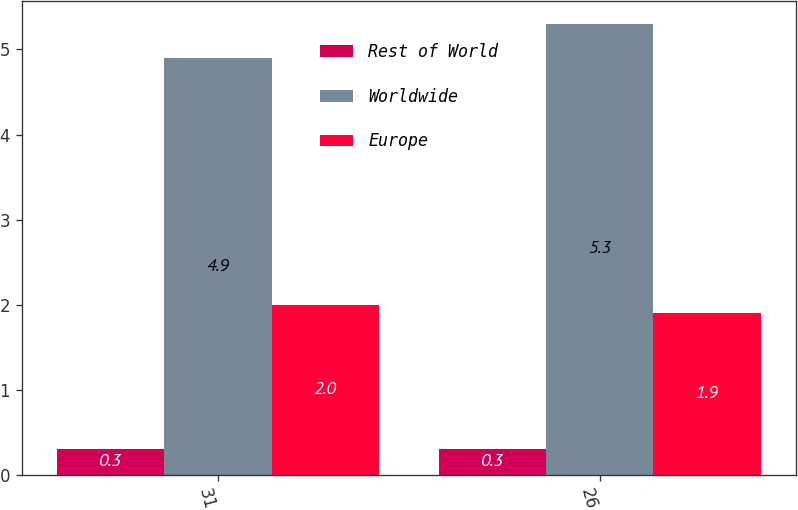Convert chart to OTSL. <chart><loc_0><loc_0><loc_500><loc_500><stacked_bar_chart><ecel><fcel>31<fcel>26<nl><fcel>Rest of World<fcel>0.3<fcel>0.3<nl><fcel>Worldwide<fcel>4.9<fcel>5.3<nl><fcel>Europe<fcel>2<fcel>1.9<nl></chart> 